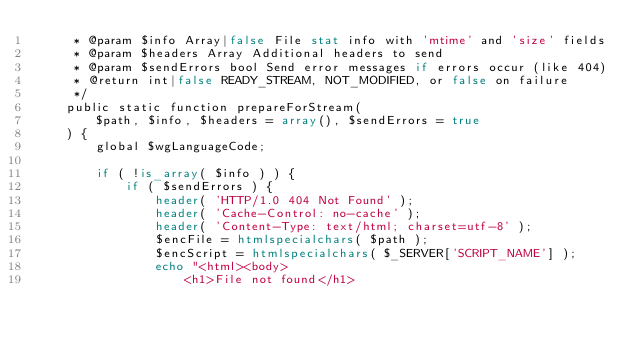<code> <loc_0><loc_0><loc_500><loc_500><_PHP_>	 * @param $info Array|false File stat info with 'mtime' and 'size' fields
	 * @param $headers Array Additional headers to send
	 * @param $sendErrors bool Send error messages if errors occur (like 404)
	 * @return int|false READY_STREAM, NOT_MODIFIED, or false on failure
	 */
	public static function prepareForStream(
		$path, $info, $headers = array(), $sendErrors = true
	) {
		global $wgLanguageCode;

		if ( !is_array( $info ) ) {
			if ( $sendErrors ) {
				header( 'HTTP/1.0 404 Not Found' );
				header( 'Cache-Control: no-cache' );
				header( 'Content-Type: text/html; charset=utf-8' );
				$encFile = htmlspecialchars( $path );
				$encScript = htmlspecialchars( $_SERVER['SCRIPT_NAME'] );
				echo "<html><body>
					<h1>File not found</h1></code> 